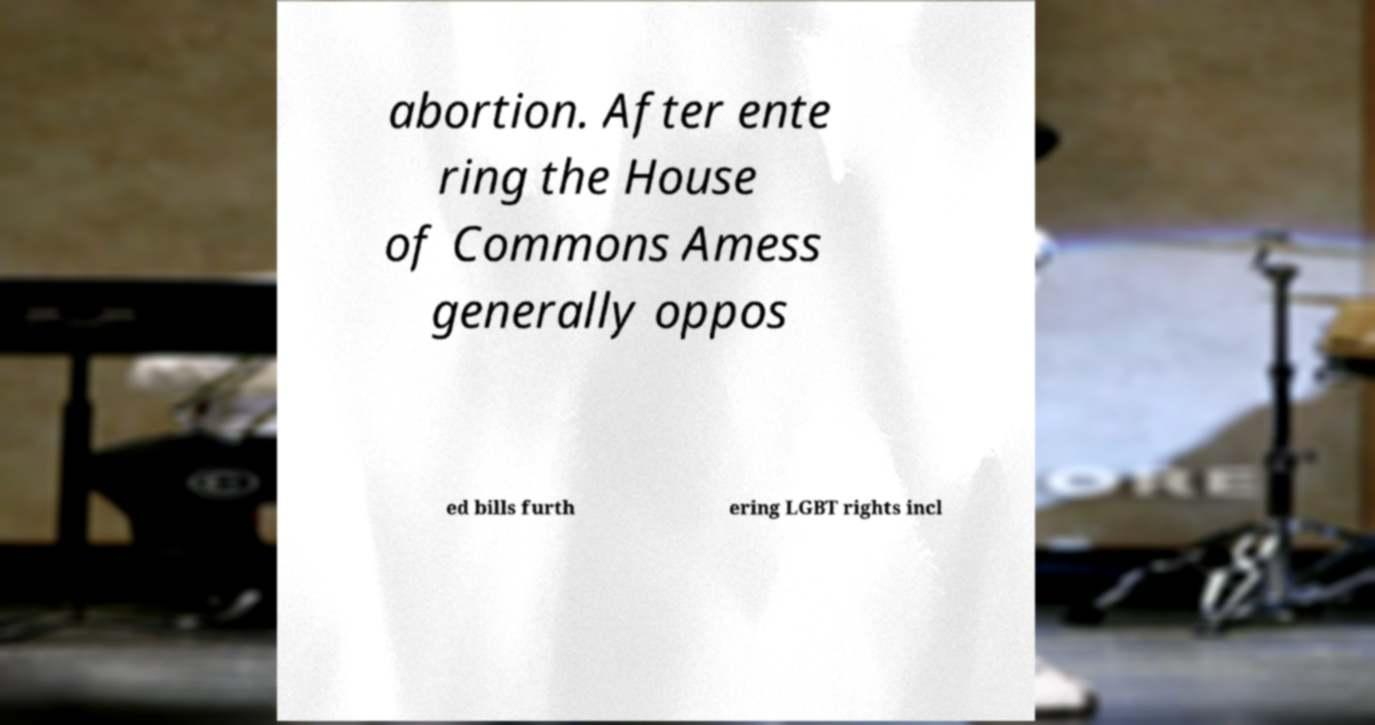Can you accurately transcribe the text from the provided image for me? abortion. After ente ring the House of Commons Amess generally oppos ed bills furth ering LGBT rights incl 